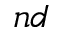<formula> <loc_0><loc_0><loc_500><loc_500>n d</formula> 